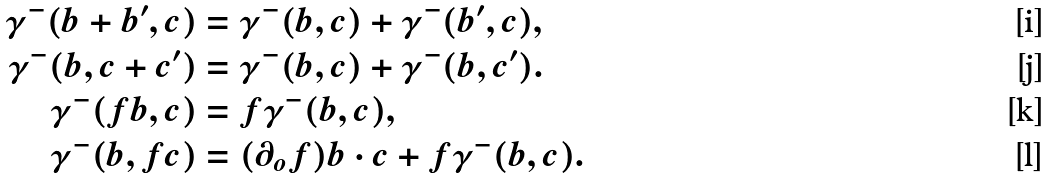Convert formula to latex. <formula><loc_0><loc_0><loc_500><loc_500>\gamma ^ { - } ( b + b ^ { \prime } , c ) & = \gamma ^ { - } ( b , c ) + \gamma ^ { - } ( b ^ { \prime } , c ) , \\ \gamma ^ { - } ( b , c + c ^ { \prime } ) & = \gamma ^ { - } ( b , c ) + \gamma ^ { - } ( b , c ^ { \prime } ) . \\ \gamma ^ { - } ( f b , c ) & = f \gamma ^ { - } ( b , c ) , \\ \gamma ^ { - } ( b , f c ) & = ( \partial _ { o } f ) b \cdot c + f \gamma ^ { - } ( b , c ) .</formula> 